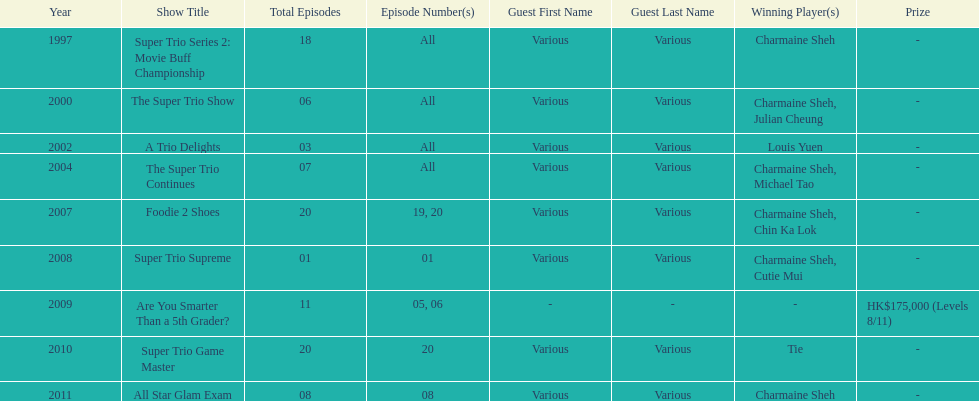What is the number of tv shows that charmaine sheh has appeared on? 9. 